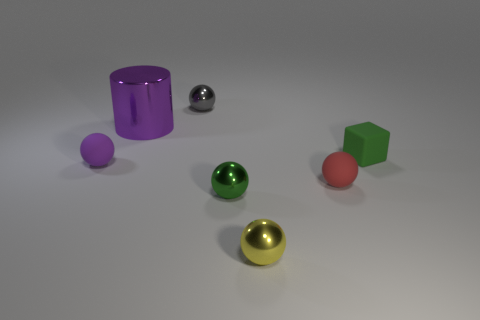Subtract all small red rubber balls. How many balls are left? 4 Add 1 large purple objects. How many objects exist? 8 Subtract all red balls. How many balls are left? 4 Subtract all cubes. How many objects are left? 6 Subtract 3 balls. How many balls are left? 2 Add 4 small rubber cubes. How many small rubber cubes exist? 5 Subtract 0 blue balls. How many objects are left? 7 Subtract all gray balls. Subtract all blue blocks. How many balls are left? 4 Subtract all red cylinders. Subtract all red matte things. How many objects are left? 6 Add 5 purple metallic things. How many purple metallic things are left? 6 